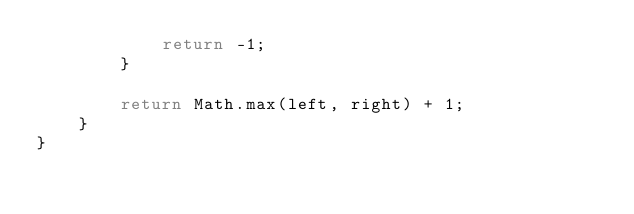Convert code to text. <code><loc_0><loc_0><loc_500><loc_500><_Java_>            return -1;
        }

        return Math.max(left, right) + 1;
    }
}
</code> 